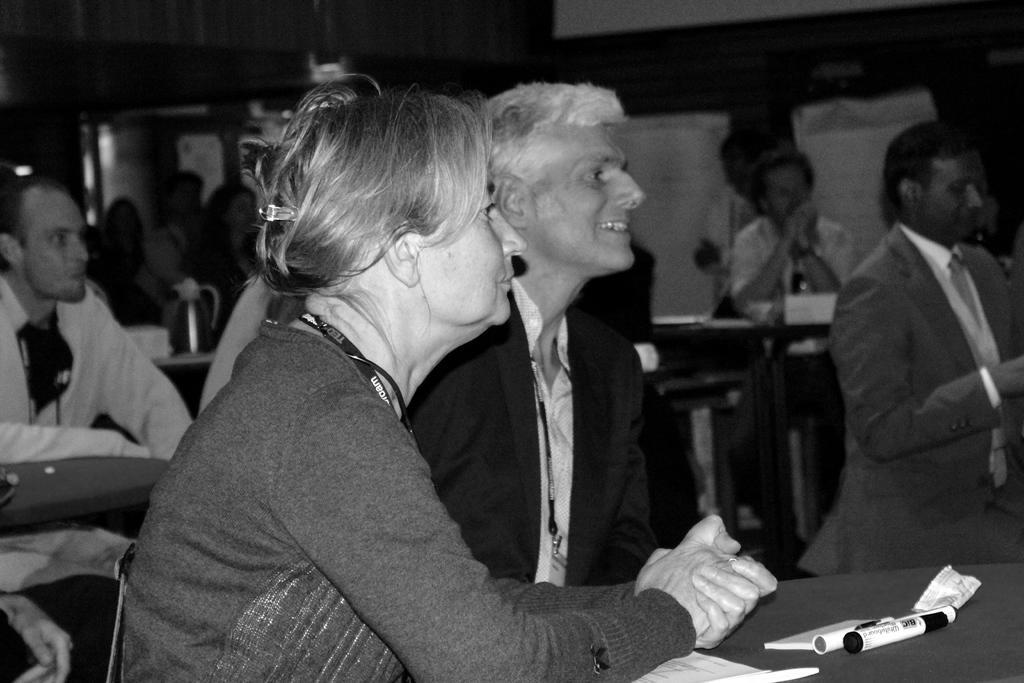Could you give a brief overview of what you see in this image? In this image we can see few people sitting on chairs in a room and there are tables, on the table there are pens and paper and on other table there is a jug and in the background there is a wall with posters. 